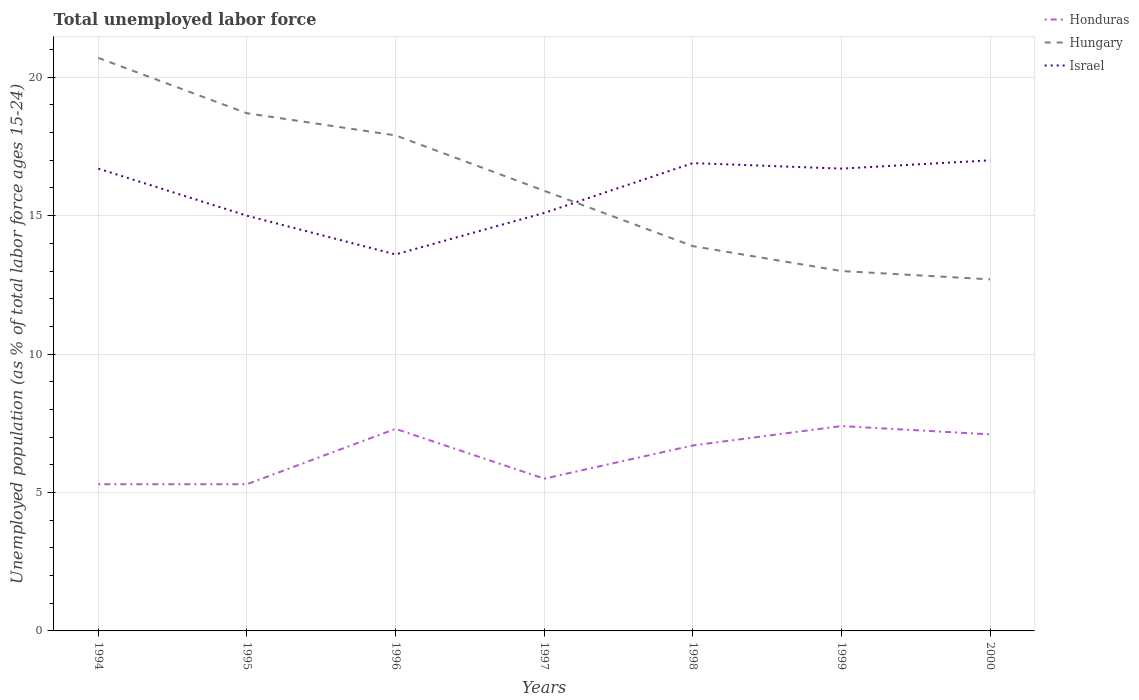How many different coloured lines are there?
Provide a succinct answer. 3. Does the line corresponding to Honduras intersect with the line corresponding to Israel?
Make the answer very short. No. Is the number of lines equal to the number of legend labels?
Make the answer very short. Yes. Across all years, what is the maximum percentage of unemployed population in in Honduras?
Make the answer very short. 5.3. In which year was the percentage of unemployed population in in Hungary maximum?
Offer a very short reply. 2000. What is the total percentage of unemployed population in in Israel in the graph?
Your answer should be very brief. -1.7. What is the difference between the highest and the second highest percentage of unemployed population in in Honduras?
Your answer should be very brief. 2.1. What is the difference between the highest and the lowest percentage of unemployed population in in Hungary?
Ensure brevity in your answer.  3. Is the percentage of unemployed population in in Hungary strictly greater than the percentage of unemployed population in in Honduras over the years?
Your answer should be very brief. No. How many lines are there?
Ensure brevity in your answer.  3. How many years are there in the graph?
Your answer should be very brief. 7. What is the difference between two consecutive major ticks on the Y-axis?
Ensure brevity in your answer.  5. Are the values on the major ticks of Y-axis written in scientific E-notation?
Your response must be concise. No. Does the graph contain any zero values?
Make the answer very short. No. Where does the legend appear in the graph?
Provide a succinct answer. Top right. How are the legend labels stacked?
Give a very brief answer. Vertical. What is the title of the graph?
Make the answer very short. Total unemployed labor force. What is the label or title of the Y-axis?
Your answer should be very brief. Unemployed population (as % of total labor force ages 15-24). What is the Unemployed population (as % of total labor force ages 15-24) in Honduras in 1994?
Provide a succinct answer. 5.3. What is the Unemployed population (as % of total labor force ages 15-24) of Hungary in 1994?
Make the answer very short. 20.7. What is the Unemployed population (as % of total labor force ages 15-24) in Israel in 1994?
Provide a short and direct response. 16.7. What is the Unemployed population (as % of total labor force ages 15-24) of Honduras in 1995?
Your answer should be very brief. 5.3. What is the Unemployed population (as % of total labor force ages 15-24) in Hungary in 1995?
Keep it short and to the point. 18.7. What is the Unemployed population (as % of total labor force ages 15-24) of Honduras in 1996?
Offer a very short reply. 7.3. What is the Unemployed population (as % of total labor force ages 15-24) in Hungary in 1996?
Your answer should be very brief. 17.9. What is the Unemployed population (as % of total labor force ages 15-24) in Israel in 1996?
Provide a short and direct response. 13.6. What is the Unemployed population (as % of total labor force ages 15-24) of Honduras in 1997?
Offer a terse response. 5.5. What is the Unemployed population (as % of total labor force ages 15-24) in Hungary in 1997?
Make the answer very short. 15.9. What is the Unemployed population (as % of total labor force ages 15-24) in Israel in 1997?
Your answer should be very brief. 15.1. What is the Unemployed population (as % of total labor force ages 15-24) of Honduras in 1998?
Give a very brief answer. 6.7. What is the Unemployed population (as % of total labor force ages 15-24) of Hungary in 1998?
Provide a short and direct response. 13.9. What is the Unemployed population (as % of total labor force ages 15-24) of Israel in 1998?
Provide a short and direct response. 16.9. What is the Unemployed population (as % of total labor force ages 15-24) of Honduras in 1999?
Ensure brevity in your answer.  7.4. What is the Unemployed population (as % of total labor force ages 15-24) in Israel in 1999?
Your response must be concise. 16.7. What is the Unemployed population (as % of total labor force ages 15-24) in Honduras in 2000?
Provide a succinct answer. 7.1. What is the Unemployed population (as % of total labor force ages 15-24) in Hungary in 2000?
Ensure brevity in your answer.  12.7. Across all years, what is the maximum Unemployed population (as % of total labor force ages 15-24) in Honduras?
Your answer should be very brief. 7.4. Across all years, what is the maximum Unemployed population (as % of total labor force ages 15-24) in Hungary?
Ensure brevity in your answer.  20.7. Across all years, what is the minimum Unemployed population (as % of total labor force ages 15-24) of Honduras?
Offer a terse response. 5.3. Across all years, what is the minimum Unemployed population (as % of total labor force ages 15-24) in Hungary?
Give a very brief answer. 12.7. Across all years, what is the minimum Unemployed population (as % of total labor force ages 15-24) in Israel?
Your response must be concise. 13.6. What is the total Unemployed population (as % of total labor force ages 15-24) of Honduras in the graph?
Provide a short and direct response. 44.6. What is the total Unemployed population (as % of total labor force ages 15-24) in Hungary in the graph?
Keep it short and to the point. 112.8. What is the total Unemployed population (as % of total labor force ages 15-24) of Israel in the graph?
Keep it short and to the point. 111. What is the difference between the Unemployed population (as % of total labor force ages 15-24) in Honduras in 1994 and that in 1996?
Make the answer very short. -2. What is the difference between the Unemployed population (as % of total labor force ages 15-24) of Honduras in 1994 and that in 1997?
Provide a short and direct response. -0.2. What is the difference between the Unemployed population (as % of total labor force ages 15-24) of Hungary in 1994 and that in 1997?
Provide a short and direct response. 4.8. What is the difference between the Unemployed population (as % of total labor force ages 15-24) in Hungary in 1994 and that in 1998?
Your answer should be compact. 6.8. What is the difference between the Unemployed population (as % of total labor force ages 15-24) in Israel in 1994 and that in 1998?
Ensure brevity in your answer.  -0.2. What is the difference between the Unemployed population (as % of total labor force ages 15-24) in Honduras in 1994 and that in 1999?
Your response must be concise. -2.1. What is the difference between the Unemployed population (as % of total labor force ages 15-24) of Israel in 1994 and that in 1999?
Give a very brief answer. 0. What is the difference between the Unemployed population (as % of total labor force ages 15-24) in Honduras in 1995 and that in 1996?
Ensure brevity in your answer.  -2. What is the difference between the Unemployed population (as % of total labor force ages 15-24) of Hungary in 1995 and that in 1996?
Give a very brief answer. 0.8. What is the difference between the Unemployed population (as % of total labor force ages 15-24) of Honduras in 1995 and that in 1998?
Offer a very short reply. -1.4. What is the difference between the Unemployed population (as % of total labor force ages 15-24) of Honduras in 1995 and that in 1999?
Ensure brevity in your answer.  -2.1. What is the difference between the Unemployed population (as % of total labor force ages 15-24) of Israel in 1995 and that in 1999?
Make the answer very short. -1.7. What is the difference between the Unemployed population (as % of total labor force ages 15-24) of Honduras in 1996 and that in 1997?
Make the answer very short. 1.8. What is the difference between the Unemployed population (as % of total labor force ages 15-24) in Hungary in 1996 and that in 1997?
Offer a very short reply. 2. What is the difference between the Unemployed population (as % of total labor force ages 15-24) of Hungary in 1996 and that in 1998?
Make the answer very short. 4. What is the difference between the Unemployed population (as % of total labor force ages 15-24) of Honduras in 1996 and that in 1999?
Your answer should be very brief. -0.1. What is the difference between the Unemployed population (as % of total labor force ages 15-24) in Israel in 1996 and that in 1999?
Your answer should be compact. -3.1. What is the difference between the Unemployed population (as % of total labor force ages 15-24) of Hungary in 1996 and that in 2000?
Your answer should be very brief. 5.2. What is the difference between the Unemployed population (as % of total labor force ages 15-24) in Israel in 1996 and that in 2000?
Provide a short and direct response. -3.4. What is the difference between the Unemployed population (as % of total labor force ages 15-24) of Honduras in 1997 and that in 1998?
Your response must be concise. -1.2. What is the difference between the Unemployed population (as % of total labor force ages 15-24) of Hungary in 1997 and that in 1998?
Make the answer very short. 2. What is the difference between the Unemployed population (as % of total labor force ages 15-24) in Israel in 1997 and that in 1998?
Provide a short and direct response. -1.8. What is the difference between the Unemployed population (as % of total labor force ages 15-24) of Honduras in 1997 and that in 1999?
Provide a succinct answer. -1.9. What is the difference between the Unemployed population (as % of total labor force ages 15-24) of Hungary in 1998 and that in 2000?
Offer a very short reply. 1.2. What is the difference between the Unemployed population (as % of total labor force ages 15-24) of Israel in 1998 and that in 2000?
Give a very brief answer. -0.1. What is the difference between the Unemployed population (as % of total labor force ages 15-24) of Honduras in 1999 and that in 2000?
Make the answer very short. 0.3. What is the difference between the Unemployed population (as % of total labor force ages 15-24) in Israel in 1999 and that in 2000?
Your answer should be compact. -0.3. What is the difference between the Unemployed population (as % of total labor force ages 15-24) of Honduras in 1994 and the Unemployed population (as % of total labor force ages 15-24) of Israel in 1995?
Provide a short and direct response. -9.7. What is the difference between the Unemployed population (as % of total labor force ages 15-24) in Honduras in 1994 and the Unemployed population (as % of total labor force ages 15-24) in Hungary in 1996?
Offer a very short reply. -12.6. What is the difference between the Unemployed population (as % of total labor force ages 15-24) of Honduras in 1994 and the Unemployed population (as % of total labor force ages 15-24) of Israel in 1996?
Keep it short and to the point. -8.3. What is the difference between the Unemployed population (as % of total labor force ages 15-24) in Honduras in 1994 and the Unemployed population (as % of total labor force ages 15-24) in Israel in 1997?
Keep it short and to the point. -9.8. What is the difference between the Unemployed population (as % of total labor force ages 15-24) in Hungary in 1994 and the Unemployed population (as % of total labor force ages 15-24) in Israel in 1998?
Offer a very short reply. 3.8. What is the difference between the Unemployed population (as % of total labor force ages 15-24) in Honduras in 1994 and the Unemployed population (as % of total labor force ages 15-24) in Hungary in 1999?
Offer a terse response. -7.7. What is the difference between the Unemployed population (as % of total labor force ages 15-24) in Hungary in 1994 and the Unemployed population (as % of total labor force ages 15-24) in Israel in 1999?
Your response must be concise. 4. What is the difference between the Unemployed population (as % of total labor force ages 15-24) of Honduras in 1994 and the Unemployed population (as % of total labor force ages 15-24) of Israel in 2000?
Provide a succinct answer. -11.7. What is the difference between the Unemployed population (as % of total labor force ages 15-24) of Hungary in 1994 and the Unemployed population (as % of total labor force ages 15-24) of Israel in 2000?
Ensure brevity in your answer.  3.7. What is the difference between the Unemployed population (as % of total labor force ages 15-24) in Honduras in 1995 and the Unemployed population (as % of total labor force ages 15-24) in Hungary in 1996?
Make the answer very short. -12.6. What is the difference between the Unemployed population (as % of total labor force ages 15-24) in Hungary in 1995 and the Unemployed population (as % of total labor force ages 15-24) in Israel in 1996?
Offer a very short reply. 5.1. What is the difference between the Unemployed population (as % of total labor force ages 15-24) in Honduras in 1995 and the Unemployed population (as % of total labor force ages 15-24) in Hungary in 1997?
Provide a succinct answer. -10.6. What is the difference between the Unemployed population (as % of total labor force ages 15-24) in Hungary in 1995 and the Unemployed population (as % of total labor force ages 15-24) in Israel in 1997?
Provide a succinct answer. 3.6. What is the difference between the Unemployed population (as % of total labor force ages 15-24) in Hungary in 1995 and the Unemployed population (as % of total labor force ages 15-24) in Israel in 1998?
Provide a short and direct response. 1.8. What is the difference between the Unemployed population (as % of total labor force ages 15-24) in Hungary in 1995 and the Unemployed population (as % of total labor force ages 15-24) in Israel in 1999?
Offer a terse response. 2. What is the difference between the Unemployed population (as % of total labor force ages 15-24) of Honduras in 1995 and the Unemployed population (as % of total labor force ages 15-24) of Israel in 2000?
Keep it short and to the point. -11.7. What is the difference between the Unemployed population (as % of total labor force ages 15-24) of Hungary in 1995 and the Unemployed population (as % of total labor force ages 15-24) of Israel in 2000?
Your response must be concise. 1.7. What is the difference between the Unemployed population (as % of total labor force ages 15-24) of Honduras in 1996 and the Unemployed population (as % of total labor force ages 15-24) of Hungary in 1998?
Ensure brevity in your answer.  -6.6. What is the difference between the Unemployed population (as % of total labor force ages 15-24) in Honduras in 1996 and the Unemployed population (as % of total labor force ages 15-24) in Hungary in 1999?
Offer a terse response. -5.7. What is the difference between the Unemployed population (as % of total labor force ages 15-24) in Honduras in 1996 and the Unemployed population (as % of total labor force ages 15-24) in Hungary in 2000?
Ensure brevity in your answer.  -5.4. What is the difference between the Unemployed population (as % of total labor force ages 15-24) in Hungary in 1996 and the Unemployed population (as % of total labor force ages 15-24) in Israel in 2000?
Ensure brevity in your answer.  0.9. What is the difference between the Unemployed population (as % of total labor force ages 15-24) of Honduras in 1997 and the Unemployed population (as % of total labor force ages 15-24) of Hungary in 1998?
Give a very brief answer. -8.4. What is the difference between the Unemployed population (as % of total labor force ages 15-24) of Honduras in 1997 and the Unemployed population (as % of total labor force ages 15-24) of Israel in 1998?
Keep it short and to the point. -11.4. What is the difference between the Unemployed population (as % of total labor force ages 15-24) in Honduras in 1997 and the Unemployed population (as % of total labor force ages 15-24) in Hungary in 1999?
Your response must be concise. -7.5. What is the difference between the Unemployed population (as % of total labor force ages 15-24) of Honduras in 1997 and the Unemployed population (as % of total labor force ages 15-24) of Israel in 1999?
Keep it short and to the point. -11.2. What is the difference between the Unemployed population (as % of total labor force ages 15-24) in Hungary in 1997 and the Unemployed population (as % of total labor force ages 15-24) in Israel in 1999?
Provide a short and direct response. -0.8. What is the difference between the Unemployed population (as % of total labor force ages 15-24) of Honduras in 1997 and the Unemployed population (as % of total labor force ages 15-24) of Hungary in 2000?
Ensure brevity in your answer.  -7.2. What is the difference between the Unemployed population (as % of total labor force ages 15-24) in Honduras in 1997 and the Unemployed population (as % of total labor force ages 15-24) in Israel in 2000?
Offer a terse response. -11.5. What is the difference between the Unemployed population (as % of total labor force ages 15-24) of Honduras in 1998 and the Unemployed population (as % of total labor force ages 15-24) of Hungary in 1999?
Offer a terse response. -6.3. What is the difference between the Unemployed population (as % of total labor force ages 15-24) of Honduras in 1998 and the Unemployed population (as % of total labor force ages 15-24) of Israel in 1999?
Your response must be concise. -10. What is the difference between the Unemployed population (as % of total labor force ages 15-24) of Honduras in 1998 and the Unemployed population (as % of total labor force ages 15-24) of Hungary in 2000?
Provide a short and direct response. -6. What is the difference between the Unemployed population (as % of total labor force ages 15-24) in Hungary in 1999 and the Unemployed population (as % of total labor force ages 15-24) in Israel in 2000?
Provide a succinct answer. -4. What is the average Unemployed population (as % of total labor force ages 15-24) of Honduras per year?
Give a very brief answer. 6.37. What is the average Unemployed population (as % of total labor force ages 15-24) in Hungary per year?
Keep it short and to the point. 16.11. What is the average Unemployed population (as % of total labor force ages 15-24) in Israel per year?
Give a very brief answer. 15.86. In the year 1994, what is the difference between the Unemployed population (as % of total labor force ages 15-24) in Honduras and Unemployed population (as % of total labor force ages 15-24) in Hungary?
Give a very brief answer. -15.4. In the year 1994, what is the difference between the Unemployed population (as % of total labor force ages 15-24) of Honduras and Unemployed population (as % of total labor force ages 15-24) of Israel?
Give a very brief answer. -11.4. In the year 1995, what is the difference between the Unemployed population (as % of total labor force ages 15-24) in Honduras and Unemployed population (as % of total labor force ages 15-24) in Israel?
Make the answer very short. -9.7. In the year 1997, what is the difference between the Unemployed population (as % of total labor force ages 15-24) of Honduras and Unemployed population (as % of total labor force ages 15-24) of Israel?
Provide a short and direct response. -9.6. In the year 1997, what is the difference between the Unemployed population (as % of total labor force ages 15-24) of Hungary and Unemployed population (as % of total labor force ages 15-24) of Israel?
Keep it short and to the point. 0.8. In the year 1998, what is the difference between the Unemployed population (as % of total labor force ages 15-24) in Honduras and Unemployed population (as % of total labor force ages 15-24) in Hungary?
Keep it short and to the point. -7.2. In the year 1998, what is the difference between the Unemployed population (as % of total labor force ages 15-24) in Honduras and Unemployed population (as % of total labor force ages 15-24) in Israel?
Offer a very short reply. -10.2. In the year 1999, what is the difference between the Unemployed population (as % of total labor force ages 15-24) of Hungary and Unemployed population (as % of total labor force ages 15-24) of Israel?
Ensure brevity in your answer.  -3.7. In the year 2000, what is the difference between the Unemployed population (as % of total labor force ages 15-24) in Honduras and Unemployed population (as % of total labor force ages 15-24) in Hungary?
Give a very brief answer. -5.6. In the year 2000, what is the difference between the Unemployed population (as % of total labor force ages 15-24) of Hungary and Unemployed population (as % of total labor force ages 15-24) of Israel?
Keep it short and to the point. -4.3. What is the ratio of the Unemployed population (as % of total labor force ages 15-24) of Honduras in 1994 to that in 1995?
Provide a succinct answer. 1. What is the ratio of the Unemployed population (as % of total labor force ages 15-24) in Hungary in 1994 to that in 1995?
Offer a very short reply. 1.11. What is the ratio of the Unemployed population (as % of total labor force ages 15-24) of Israel in 1994 to that in 1995?
Your answer should be compact. 1.11. What is the ratio of the Unemployed population (as % of total labor force ages 15-24) of Honduras in 1994 to that in 1996?
Give a very brief answer. 0.73. What is the ratio of the Unemployed population (as % of total labor force ages 15-24) of Hungary in 1994 to that in 1996?
Give a very brief answer. 1.16. What is the ratio of the Unemployed population (as % of total labor force ages 15-24) of Israel in 1994 to that in 1996?
Make the answer very short. 1.23. What is the ratio of the Unemployed population (as % of total labor force ages 15-24) of Honduras in 1994 to that in 1997?
Provide a short and direct response. 0.96. What is the ratio of the Unemployed population (as % of total labor force ages 15-24) of Hungary in 1994 to that in 1997?
Ensure brevity in your answer.  1.3. What is the ratio of the Unemployed population (as % of total labor force ages 15-24) in Israel in 1994 to that in 1997?
Keep it short and to the point. 1.11. What is the ratio of the Unemployed population (as % of total labor force ages 15-24) in Honduras in 1994 to that in 1998?
Keep it short and to the point. 0.79. What is the ratio of the Unemployed population (as % of total labor force ages 15-24) of Hungary in 1994 to that in 1998?
Offer a terse response. 1.49. What is the ratio of the Unemployed population (as % of total labor force ages 15-24) in Honduras in 1994 to that in 1999?
Offer a very short reply. 0.72. What is the ratio of the Unemployed population (as % of total labor force ages 15-24) of Hungary in 1994 to that in 1999?
Offer a very short reply. 1.59. What is the ratio of the Unemployed population (as % of total labor force ages 15-24) of Israel in 1994 to that in 1999?
Offer a terse response. 1. What is the ratio of the Unemployed population (as % of total labor force ages 15-24) of Honduras in 1994 to that in 2000?
Your answer should be very brief. 0.75. What is the ratio of the Unemployed population (as % of total labor force ages 15-24) in Hungary in 1994 to that in 2000?
Offer a very short reply. 1.63. What is the ratio of the Unemployed population (as % of total labor force ages 15-24) in Israel in 1994 to that in 2000?
Give a very brief answer. 0.98. What is the ratio of the Unemployed population (as % of total labor force ages 15-24) of Honduras in 1995 to that in 1996?
Provide a succinct answer. 0.73. What is the ratio of the Unemployed population (as % of total labor force ages 15-24) of Hungary in 1995 to that in 1996?
Your answer should be compact. 1.04. What is the ratio of the Unemployed population (as % of total labor force ages 15-24) of Israel in 1995 to that in 1996?
Provide a short and direct response. 1.1. What is the ratio of the Unemployed population (as % of total labor force ages 15-24) of Honduras in 1995 to that in 1997?
Your response must be concise. 0.96. What is the ratio of the Unemployed population (as % of total labor force ages 15-24) in Hungary in 1995 to that in 1997?
Your response must be concise. 1.18. What is the ratio of the Unemployed population (as % of total labor force ages 15-24) in Honduras in 1995 to that in 1998?
Ensure brevity in your answer.  0.79. What is the ratio of the Unemployed population (as % of total labor force ages 15-24) of Hungary in 1995 to that in 1998?
Make the answer very short. 1.35. What is the ratio of the Unemployed population (as % of total labor force ages 15-24) in Israel in 1995 to that in 1998?
Give a very brief answer. 0.89. What is the ratio of the Unemployed population (as % of total labor force ages 15-24) of Honduras in 1995 to that in 1999?
Make the answer very short. 0.72. What is the ratio of the Unemployed population (as % of total labor force ages 15-24) of Hungary in 1995 to that in 1999?
Your response must be concise. 1.44. What is the ratio of the Unemployed population (as % of total labor force ages 15-24) in Israel in 1995 to that in 1999?
Offer a terse response. 0.9. What is the ratio of the Unemployed population (as % of total labor force ages 15-24) of Honduras in 1995 to that in 2000?
Offer a very short reply. 0.75. What is the ratio of the Unemployed population (as % of total labor force ages 15-24) in Hungary in 1995 to that in 2000?
Provide a short and direct response. 1.47. What is the ratio of the Unemployed population (as % of total labor force ages 15-24) of Israel in 1995 to that in 2000?
Your response must be concise. 0.88. What is the ratio of the Unemployed population (as % of total labor force ages 15-24) in Honduras in 1996 to that in 1997?
Ensure brevity in your answer.  1.33. What is the ratio of the Unemployed population (as % of total labor force ages 15-24) of Hungary in 1996 to that in 1997?
Ensure brevity in your answer.  1.13. What is the ratio of the Unemployed population (as % of total labor force ages 15-24) in Israel in 1996 to that in 1997?
Ensure brevity in your answer.  0.9. What is the ratio of the Unemployed population (as % of total labor force ages 15-24) in Honduras in 1996 to that in 1998?
Provide a short and direct response. 1.09. What is the ratio of the Unemployed population (as % of total labor force ages 15-24) in Hungary in 1996 to that in 1998?
Give a very brief answer. 1.29. What is the ratio of the Unemployed population (as % of total labor force ages 15-24) of Israel in 1996 to that in 1998?
Keep it short and to the point. 0.8. What is the ratio of the Unemployed population (as % of total labor force ages 15-24) in Honduras in 1996 to that in 1999?
Provide a succinct answer. 0.99. What is the ratio of the Unemployed population (as % of total labor force ages 15-24) of Hungary in 1996 to that in 1999?
Make the answer very short. 1.38. What is the ratio of the Unemployed population (as % of total labor force ages 15-24) of Israel in 1996 to that in 1999?
Give a very brief answer. 0.81. What is the ratio of the Unemployed population (as % of total labor force ages 15-24) in Honduras in 1996 to that in 2000?
Your answer should be compact. 1.03. What is the ratio of the Unemployed population (as % of total labor force ages 15-24) of Hungary in 1996 to that in 2000?
Your response must be concise. 1.41. What is the ratio of the Unemployed population (as % of total labor force ages 15-24) in Israel in 1996 to that in 2000?
Offer a very short reply. 0.8. What is the ratio of the Unemployed population (as % of total labor force ages 15-24) in Honduras in 1997 to that in 1998?
Offer a very short reply. 0.82. What is the ratio of the Unemployed population (as % of total labor force ages 15-24) in Hungary in 1997 to that in 1998?
Give a very brief answer. 1.14. What is the ratio of the Unemployed population (as % of total labor force ages 15-24) of Israel in 1997 to that in 1998?
Provide a succinct answer. 0.89. What is the ratio of the Unemployed population (as % of total labor force ages 15-24) of Honduras in 1997 to that in 1999?
Give a very brief answer. 0.74. What is the ratio of the Unemployed population (as % of total labor force ages 15-24) in Hungary in 1997 to that in 1999?
Give a very brief answer. 1.22. What is the ratio of the Unemployed population (as % of total labor force ages 15-24) in Israel in 1997 to that in 1999?
Your answer should be very brief. 0.9. What is the ratio of the Unemployed population (as % of total labor force ages 15-24) of Honduras in 1997 to that in 2000?
Make the answer very short. 0.77. What is the ratio of the Unemployed population (as % of total labor force ages 15-24) of Hungary in 1997 to that in 2000?
Offer a terse response. 1.25. What is the ratio of the Unemployed population (as % of total labor force ages 15-24) in Israel in 1997 to that in 2000?
Offer a very short reply. 0.89. What is the ratio of the Unemployed population (as % of total labor force ages 15-24) of Honduras in 1998 to that in 1999?
Provide a short and direct response. 0.91. What is the ratio of the Unemployed population (as % of total labor force ages 15-24) of Hungary in 1998 to that in 1999?
Give a very brief answer. 1.07. What is the ratio of the Unemployed population (as % of total labor force ages 15-24) of Honduras in 1998 to that in 2000?
Provide a succinct answer. 0.94. What is the ratio of the Unemployed population (as % of total labor force ages 15-24) in Hungary in 1998 to that in 2000?
Keep it short and to the point. 1.09. What is the ratio of the Unemployed population (as % of total labor force ages 15-24) of Israel in 1998 to that in 2000?
Provide a short and direct response. 0.99. What is the ratio of the Unemployed population (as % of total labor force ages 15-24) in Honduras in 1999 to that in 2000?
Offer a very short reply. 1.04. What is the ratio of the Unemployed population (as % of total labor force ages 15-24) in Hungary in 1999 to that in 2000?
Ensure brevity in your answer.  1.02. What is the ratio of the Unemployed population (as % of total labor force ages 15-24) in Israel in 1999 to that in 2000?
Ensure brevity in your answer.  0.98. What is the difference between the highest and the second highest Unemployed population (as % of total labor force ages 15-24) of Honduras?
Ensure brevity in your answer.  0.1. What is the difference between the highest and the second highest Unemployed population (as % of total labor force ages 15-24) in Hungary?
Ensure brevity in your answer.  2. What is the difference between the highest and the lowest Unemployed population (as % of total labor force ages 15-24) of Honduras?
Ensure brevity in your answer.  2.1. 